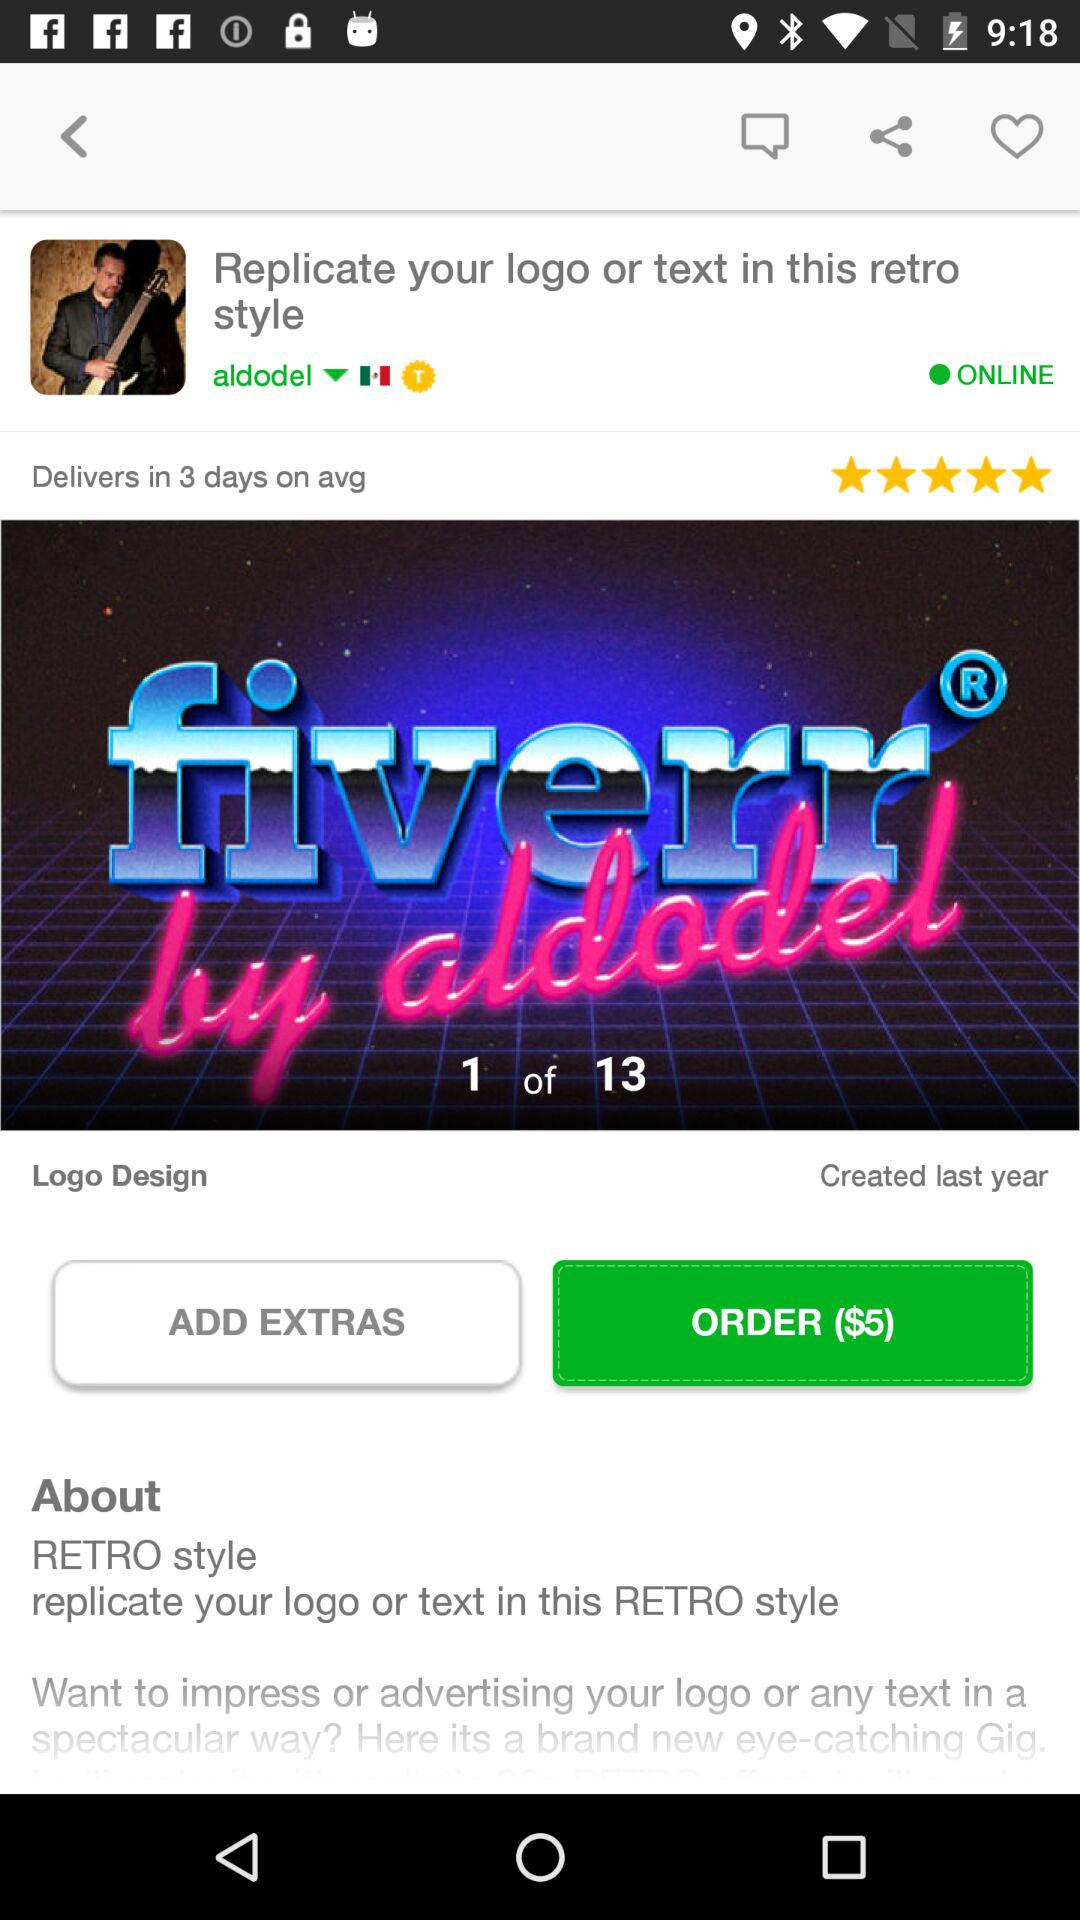How many ratings are given? The rating is 5 stars. 